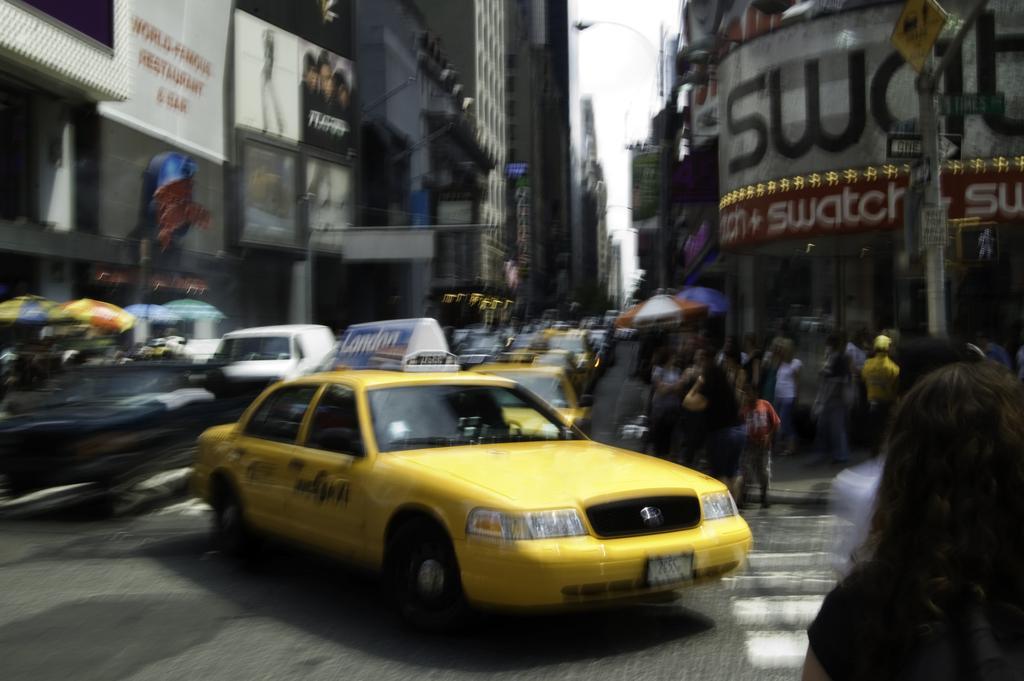In one or two sentences, can you explain what this image depicts? In this image, we can see the road, there are some cars on the road, we can see some people standing, we can see a pole and there are some buildings. 